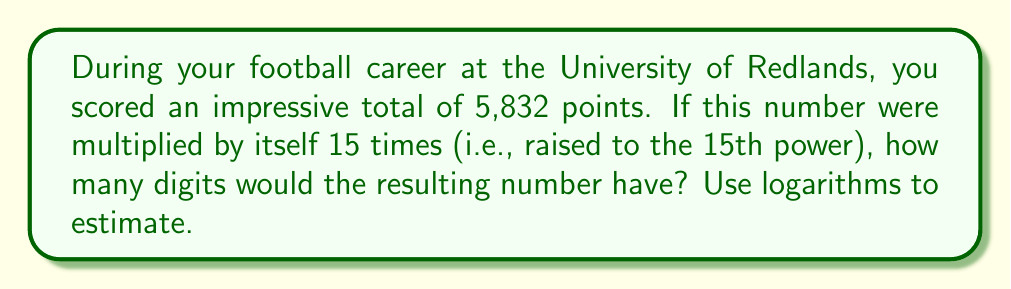Provide a solution to this math problem. Let's approach this step-by-step:

1) We need to find the number of digits in $5832^{15}$.

2) The number of digits in a number is equal to the floor of its base-10 logarithm, plus 1.

3) So, we need to calculate:
   $\lfloor \log_{10}(5832^{15}) \rfloor + 1$

4) Using the logarithm property $\log_a(x^n) = n\log_a(x)$, we can simplify:
   $\lfloor 15 \cdot \log_{10}(5832) \rfloor + 1$

5) Now, let's calculate $\log_{10}(5832)$:
   $\log_{10}(5832) \approx 3.7659$

6) Multiply by 15:
   $15 \cdot 3.7659 \approx 56.4885$

7) Take the floor of this value:
   $\lfloor 56.4885 \rfloor = 56$

8) Add 1:
   $56 + 1 = 57$

Therefore, $5832^{15}$ would have 57 digits.
Answer: 57 digits 